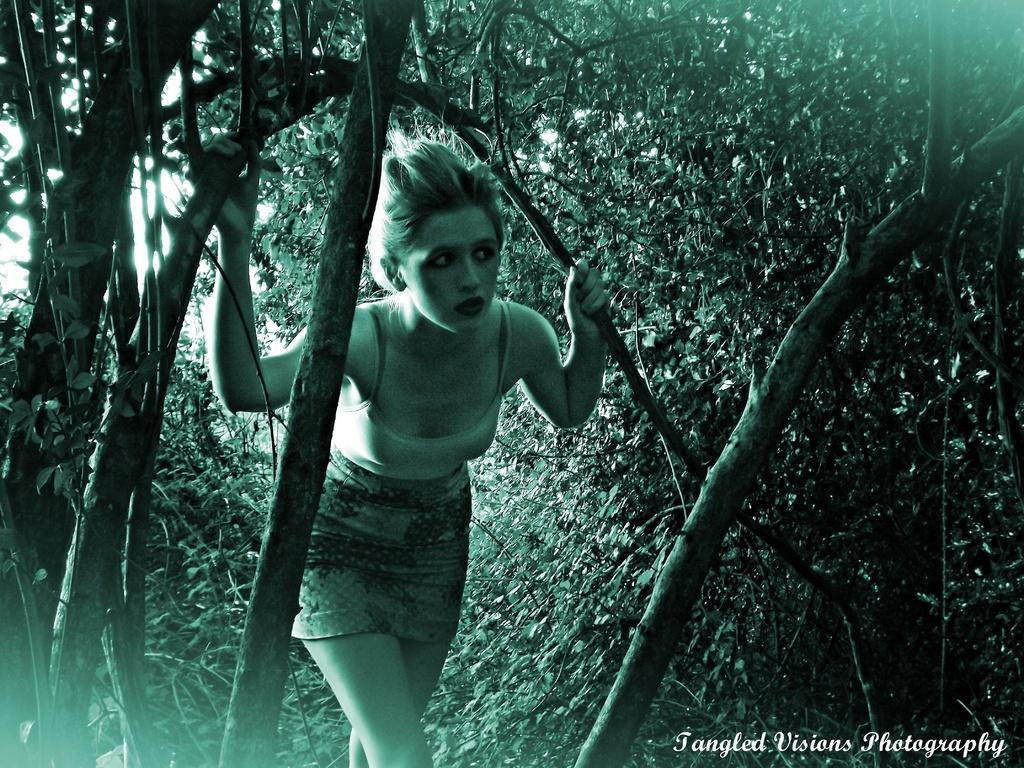Could you give a brief overview of what you see in this image? This is an edited image. I can see a woman standing and holding a branch. There are trees. At the bottom right side of the image, I can see a watermark. 